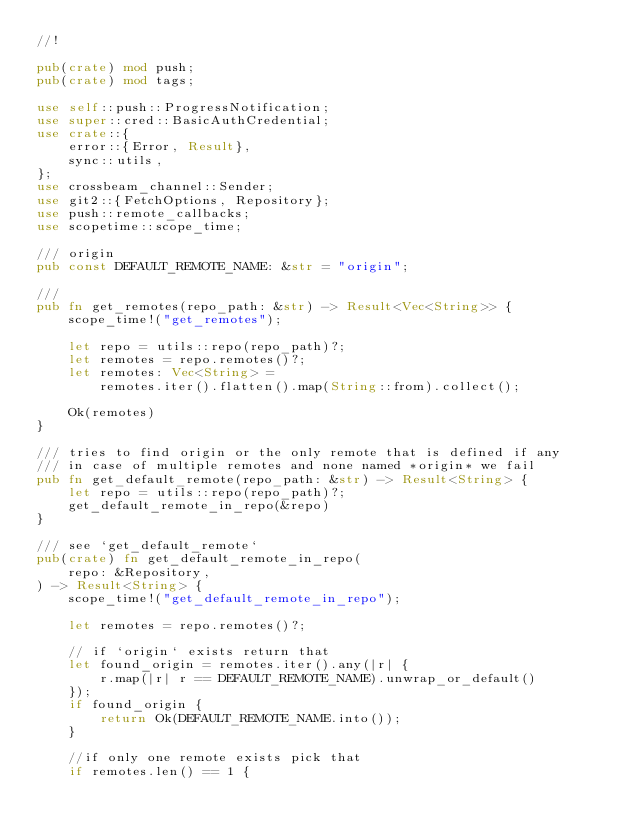<code> <loc_0><loc_0><loc_500><loc_500><_Rust_>//!

pub(crate) mod push;
pub(crate) mod tags;

use self::push::ProgressNotification;
use super::cred::BasicAuthCredential;
use crate::{
    error::{Error, Result},
    sync::utils,
};
use crossbeam_channel::Sender;
use git2::{FetchOptions, Repository};
use push::remote_callbacks;
use scopetime::scope_time;

/// origin
pub const DEFAULT_REMOTE_NAME: &str = "origin";

///
pub fn get_remotes(repo_path: &str) -> Result<Vec<String>> {
    scope_time!("get_remotes");

    let repo = utils::repo(repo_path)?;
    let remotes = repo.remotes()?;
    let remotes: Vec<String> =
        remotes.iter().flatten().map(String::from).collect();

    Ok(remotes)
}

/// tries to find origin or the only remote that is defined if any
/// in case of multiple remotes and none named *origin* we fail
pub fn get_default_remote(repo_path: &str) -> Result<String> {
    let repo = utils::repo(repo_path)?;
    get_default_remote_in_repo(&repo)
}

/// see `get_default_remote`
pub(crate) fn get_default_remote_in_repo(
    repo: &Repository,
) -> Result<String> {
    scope_time!("get_default_remote_in_repo");

    let remotes = repo.remotes()?;

    // if `origin` exists return that
    let found_origin = remotes.iter().any(|r| {
        r.map(|r| r == DEFAULT_REMOTE_NAME).unwrap_or_default()
    });
    if found_origin {
        return Ok(DEFAULT_REMOTE_NAME.into());
    }

    //if only one remote exists pick that
    if remotes.len() == 1 {</code> 